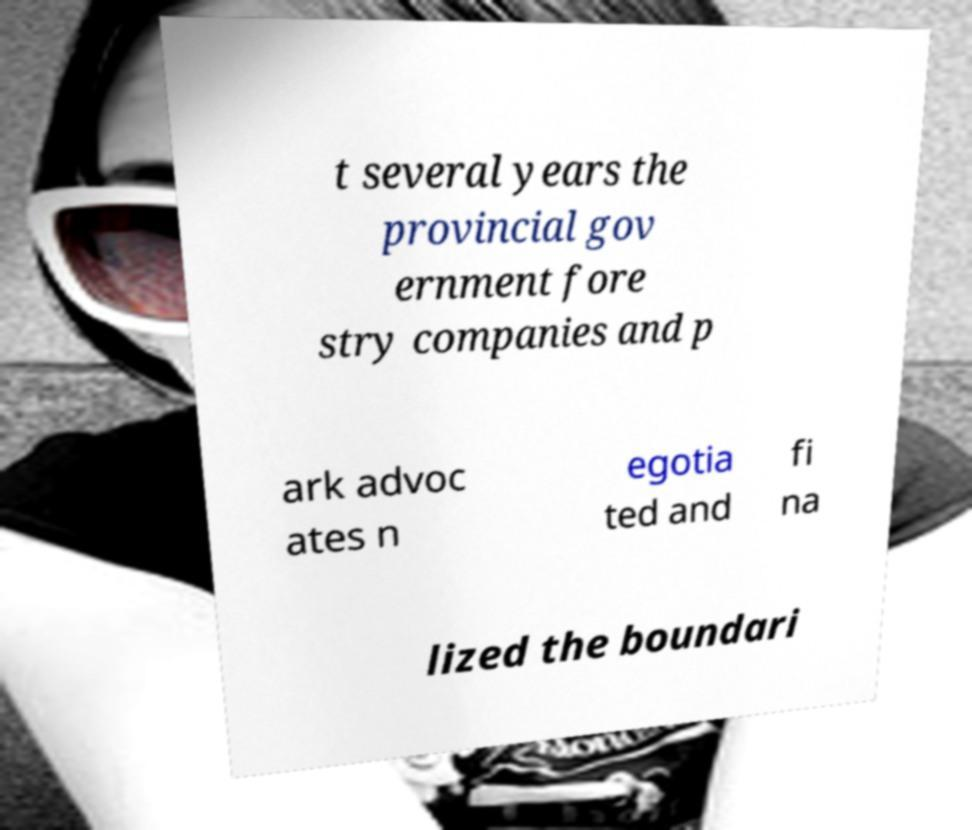There's text embedded in this image that I need extracted. Can you transcribe it verbatim? t several years the provincial gov ernment fore stry companies and p ark advoc ates n egotia ted and fi na lized the boundari 